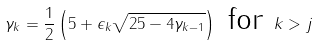<formula> <loc_0><loc_0><loc_500><loc_500>\gamma _ { k } = \frac { 1 } { 2 } \left ( 5 + \epsilon _ { k } \sqrt { 2 5 - 4 \gamma _ { k - 1 } } \right ) \text { for } k > j</formula> 